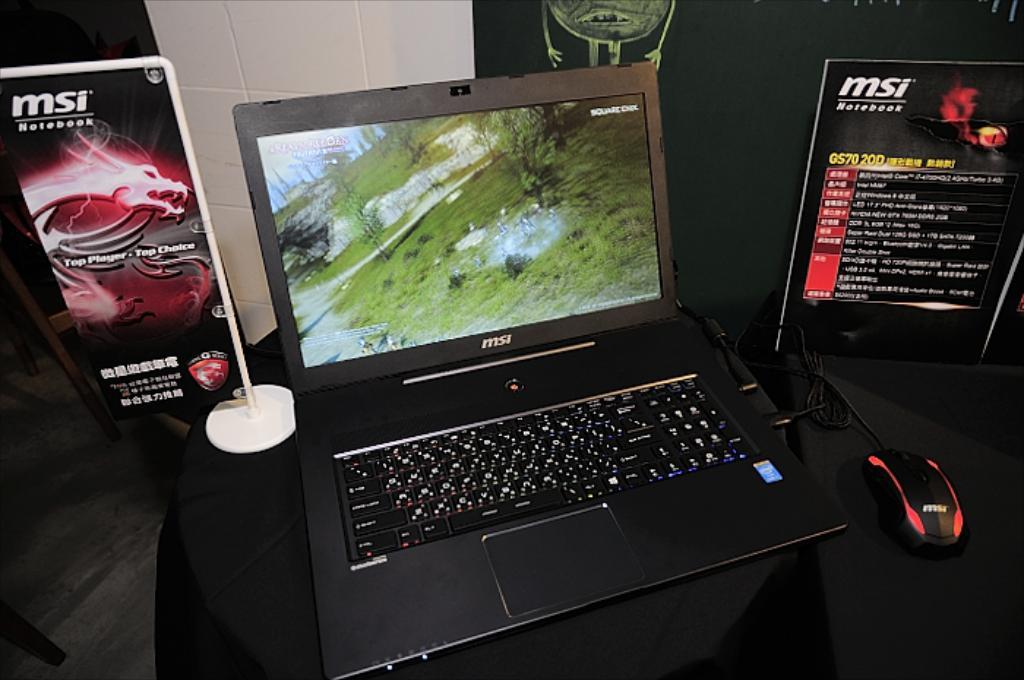<image>
Render a clear and concise summary of the photo. An MSI branded laptop is sitting between two advertisements for the msi brand. 